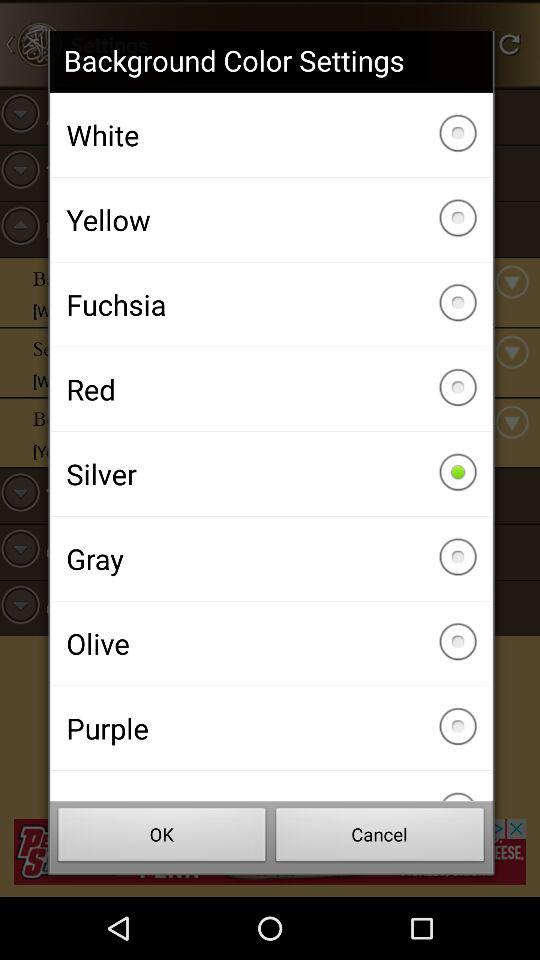Which is the selected option? The selected option is "Silver". 